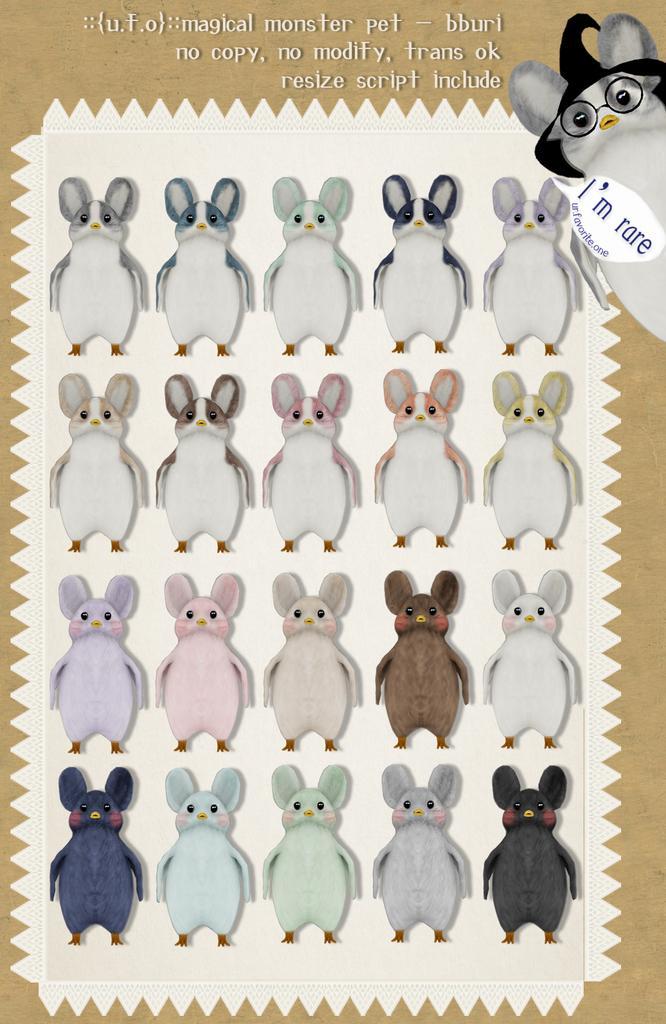Can you describe this image briefly? This image is an animated image. In which there are images of animals and on the top there is some text written on the image. 